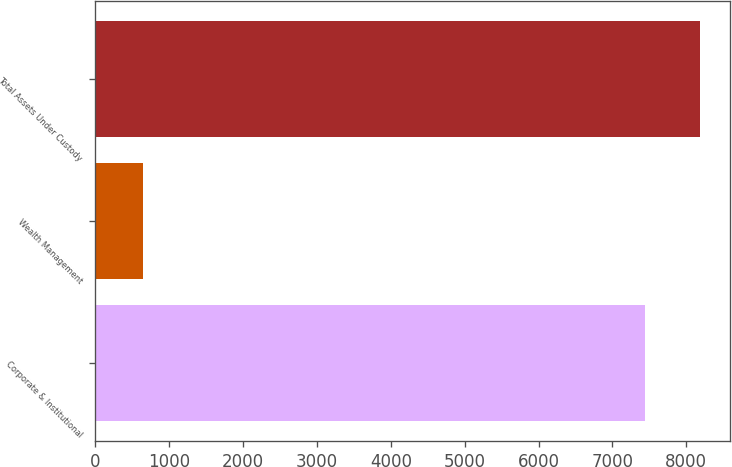<chart> <loc_0><loc_0><loc_500><loc_500><bar_chart><fcel>Corporate & Institutional<fcel>Wealth Management<fcel>Total Assets Under Custody<nl><fcel>7439.1<fcel>645.5<fcel>8183.01<nl></chart> 